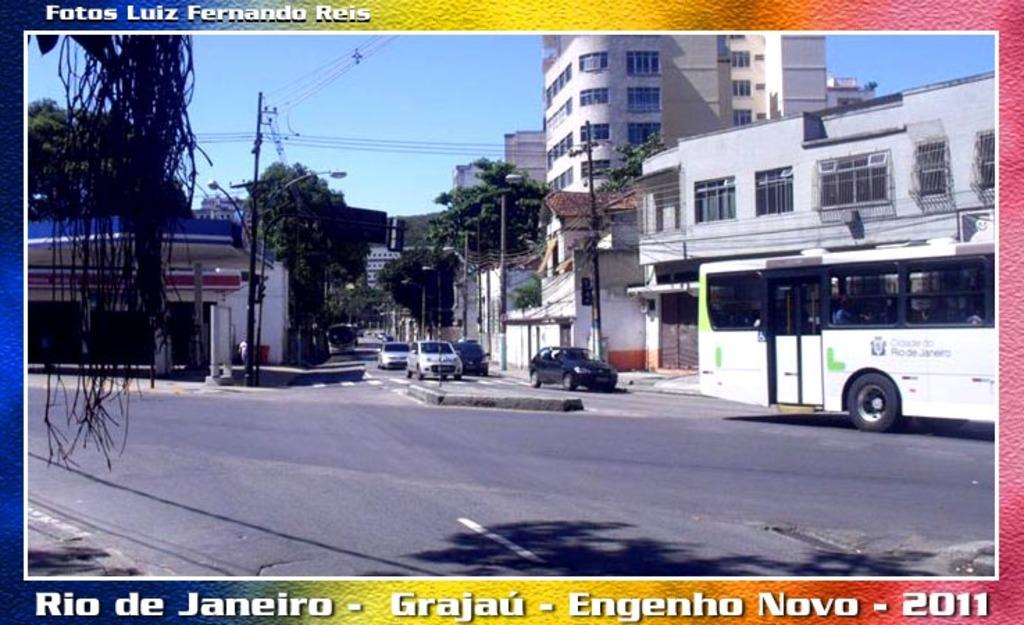<image>
Describe the image concisely. a postcard of rio de janeiro taken in 2011 